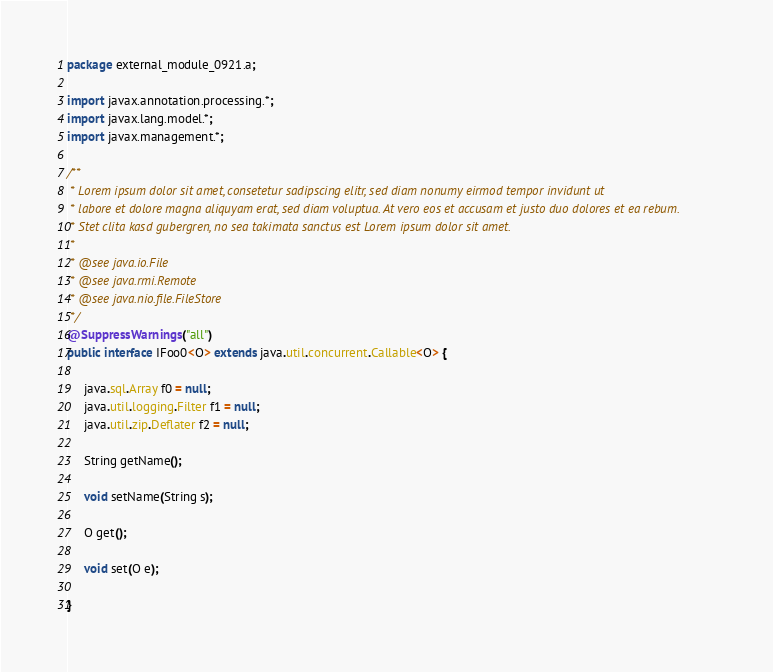Convert code to text. <code><loc_0><loc_0><loc_500><loc_500><_Java_>package external_module_0921.a;

import javax.annotation.processing.*;
import javax.lang.model.*;
import javax.management.*;

/**
 * Lorem ipsum dolor sit amet, consetetur sadipscing elitr, sed diam nonumy eirmod tempor invidunt ut 
 * labore et dolore magna aliquyam erat, sed diam voluptua. At vero eos et accusam et justo duo dolores et ea rebum. 
 * Stet clita kasd gubergren, no sea takimata sanctus est Lorem ipsum dolor sit amet. 
 *
 * @see java.io.File
 * @see java.rmi.Remote
 * @see java.nio.file.FileStore
 */
@SuppressWarnings("all")
public interface IFoo0<O> extends java.util.concurrent.Callable<O> {

	 java.sql.Array f0 = null;
	 java.util.logging.Filter f1 = null;
	 java.util.zip.Deflater f2 = null;

	 String getName();

	 void setName(String s);

	 O get();

	 void set(O e);

}
</code> 